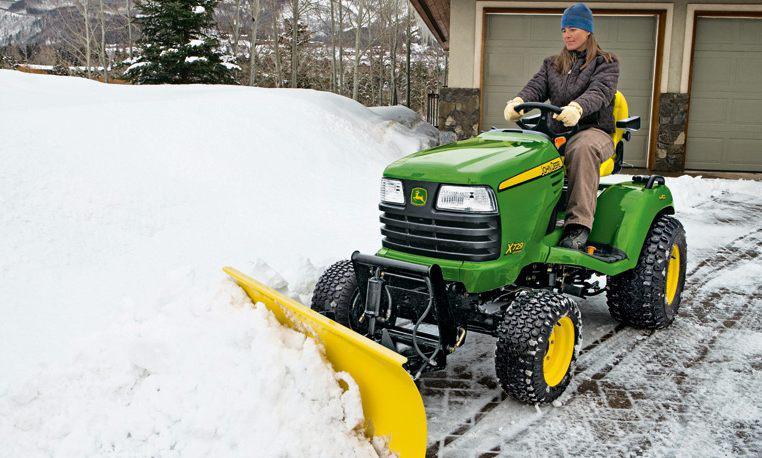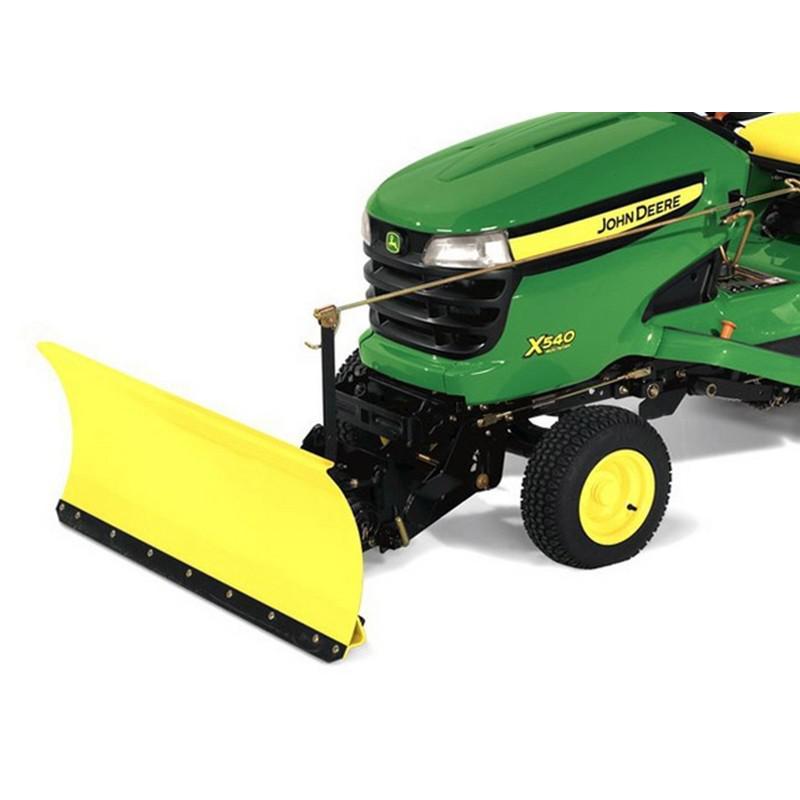The first image is the image on the left, the second image is the image on the right. Analyze the images presented: Is the assertion "An image shows a leftward-facing green tractor plowing snowy ground." valid? Answer yes or no. Yes. The first image is the image on the left, the second image is the image on the right. For the images shown, is this caption "In one image, a person wearing a coat and hat is plowing snow using a green tractor with yellow snow blade." true? Answer yes or no. Yes. 